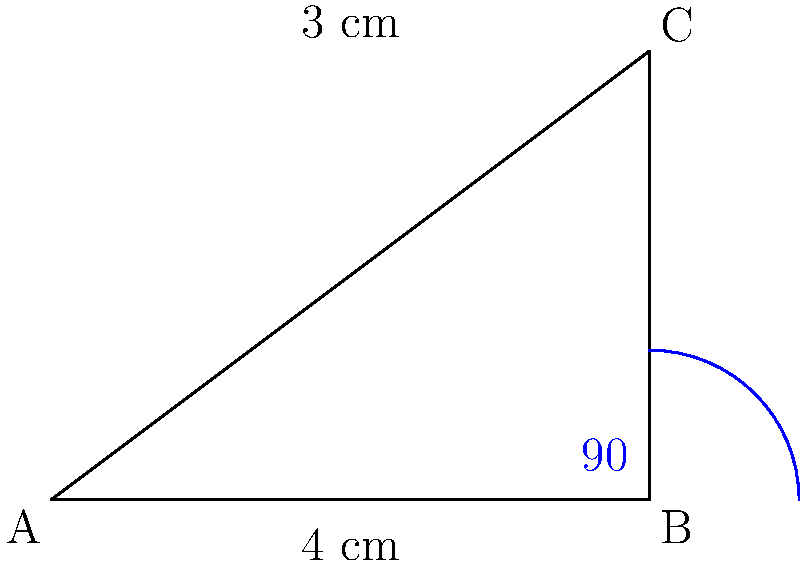In the manufacturing process of a specialized piping system, you need to ensure the proper bend angle of a pipe section. The pipe has a right-angled bend with one arm measuring 4 cm and the other arm measuring 3 cm. What is the bend angle of this pipe section? To determine the bend angle of the pipe section, we need to follow these steps:

1. Recognize that the pipe forms a right-angled triangle with the bend at one of the vertices.

2. Identify the given measurements:
   - One arm of the pipe (adjacent to the bend) is 4 cm
   - The other arm of the pipe (opposite to the bend) is 3 cm

3. Recall that in a right-angled triangle, the angle between the hypotenuse and one of the other sides is complementary to the angle between the two non-hypotenuse sides.

4. We can use the arctangent (inverse tangent) function to calculate the angle between the 4 cm side and the hypotenuse:
   $$\theta = \arctan(\frac{\text{opposite}}{\text{adjacent}}) = \arctan(\frac{3}{4})$$

5. Calculate the angle:
   $$\theta = \arctan(\frac{3}{4}) \approx 36.87°$$

6. The bend angle of the pipe is the complement of this angle, which can be calculated by subtracting it from 90°:
   $$\text{Bend angle} = 90° - 36.87° \approx 53.13°$$

Therefore, the bend angle of the pipe section is approximately 53.13°.
Answer: 53.13° 